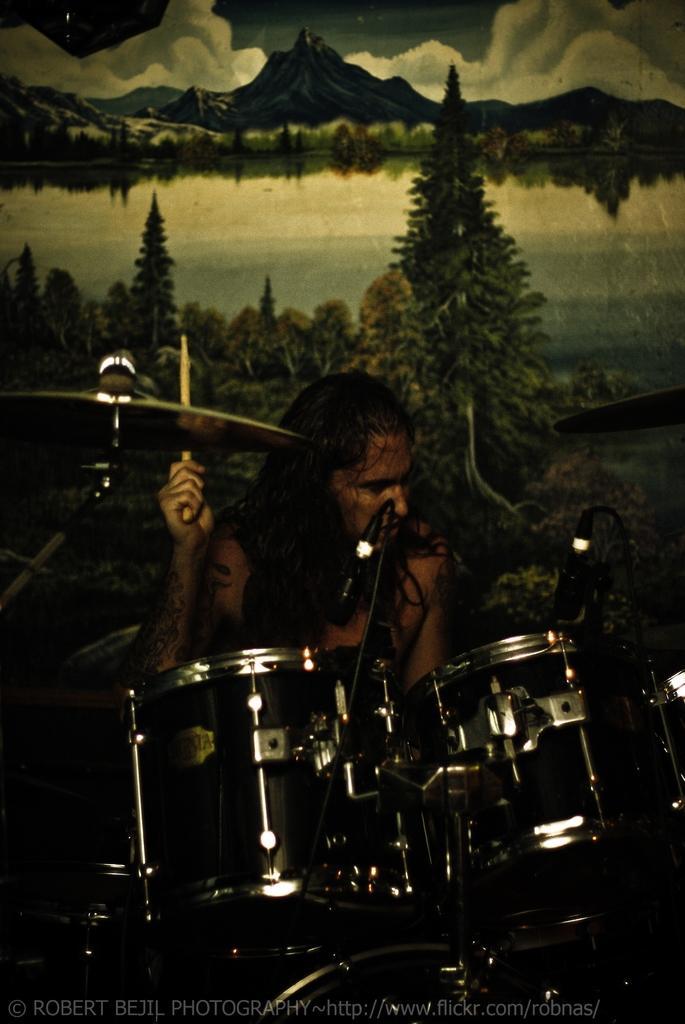In one or two sentences, can you explain what this image depicts? In this image we can see a person holding a stick in his hand. In the foreground of the image we can see drums and two microphone placed on top of the drums and in the background we can see group of trees ,water mountains and the sky. 